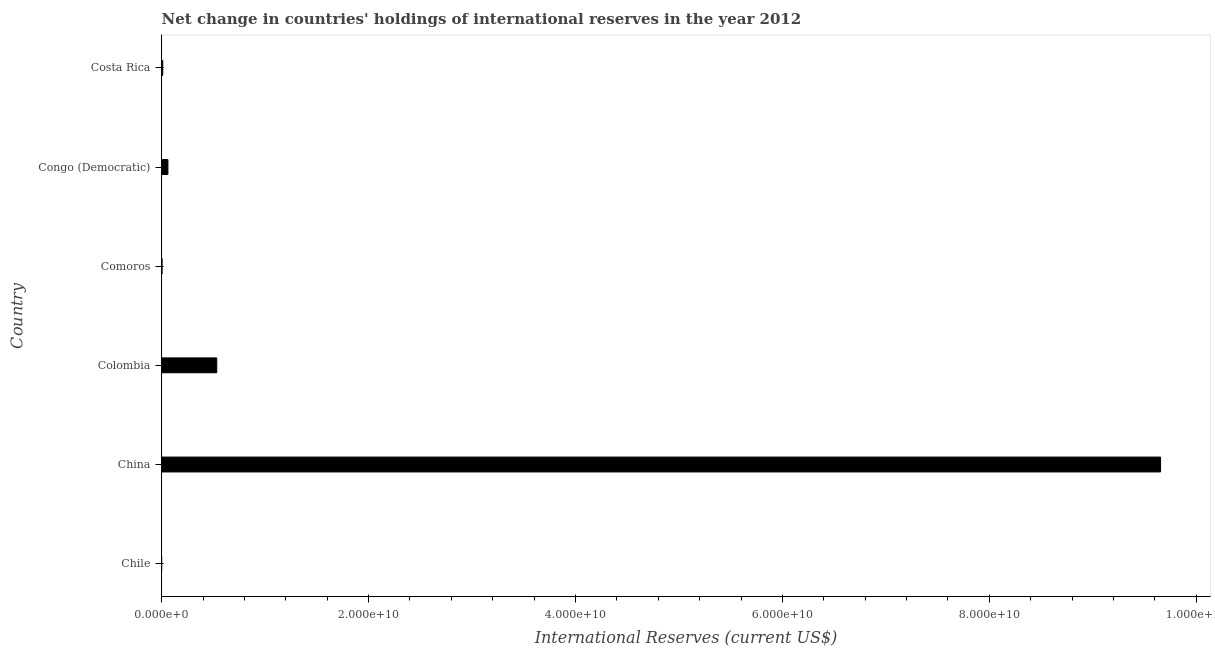What is the title of the graph?
Offer a terse response. Net change in countries' holdings of international reserves in the year 2012. What is the label or title of the X-axis?
Give a very brief answer. International Reserves (current US$). What is the reserves and related items in Comoros?
Your response must be concise. 3.07e+07. Across all countries, what is the maximum reserves and related items?
Offer a very short reply. 9.66e+1. What is the sum of the reserves and related items?
Keep it short and to the point. 1.03e+11. What is the difference between the reserves and related items in China and Comoros?
Keep it short and to the point. 9.65e+1. What is the average reserves and related items per country?
Your answer should be very brief. 1.71e+1. What is the median reserves and related items?
Give a very brief answer. 3.51e+08. In how many countries, is the reserves and related items greater than 48000000000 US$?
Offer a very short reply. 1. What is the ratio of the reserves and related items in China to that in Comoros?
Give a very brief answer. 3144.3. Is the reserves and related items in Comoros less than that in Congo (Democratic)?
Keep it short and to the point. Yes. Is the difference between the reserves and related items in China and Costa Rica greater than the difference between any two countries?
Provide a short and direct response. No. What is the difference between the highest and the second highest reserves and related items?
Your answer should be compact. 9.12e+1. Is the sum of the reserves and related items in China and Colombia greater than the maximum reserves and related items across all countries?
Your answer should be compact. Yes. What is the difference between the highest and the lowest reserves and related items?
Ensure brevity in your answer.  9.66e+1. In how many countries, is the reserves and related items greater than the average reserves and related items taken over all countries?
Provide a short and direct response. 1. Are all the bars in the graph horizontal?
Provide a short and direct response. Yes. What is the International Reserves (current US$) of China?
Ensure brevity in your answer.  9.66e+1. What is the International Reserves (current US$) in Colombia?
Make the answer very short. 5.32e+09. What is the International Reserves (current US$) of Comoros?
Give a very brief answer. 3.07e+07. What is the International Reserves (current US$) of Congo (Democratic)?
Provide a short and direct response. 6.01e+08. What is the International Reserves (current US$) in Costa Rica?
Your answer should be very brief. 1.01e+08. What is the difference between the International Reserves (current US$) in China and Colombia?
Offer a very short reply. 9.12e+1. What is the difference between the International Reserves (current US$) in China and Comoros?
Your response must be concise. 9.65e+1. What is the difference between the International Reserves (current US$) in China and Congo (Democratic)?
Your response must be concise. 9.60e+1. What is the difference between the International Reserves (current US$) in China and Costa Rica?
Provide a short and direct response. 9.65e+1. What is the difference between the International Reserves (current US$) in Colombia and Comoros?
Provide a short and direct response. 5.29e+09. What is the difference between the International Reserves (current US$) in Colombia and Congo (Democratic)?
Make the answer very short. 4.72e+09. What is the difference between the International Reserves (current US$) in Colombia and Costa Rica?
Your answer should be compact. 5.22e+09. What is the difference between the International Reserves (current US$) in Comoros and Congo (Democratic)?
Ensure brevity in your answer.  -5.70e+08. What is the difference between the International Reserves (current US$) in Comoros and Costa Rica?
Provide a succinct answer. -6.99e+07. What is the difference between the International Reserves (current US$) in Congo (Democratic) and Costa Rica?
Offer a terse response. 5.00e+08. What is the ratio of the International Reserves (current US$) in China to that in Colombia?
Your answer should be compact. 18.14. What is the ratio of the International Reserves (current US$) in China to that in Comoros?
Your answer should be very brief. 3144.3. What is the ratio of the International Reserves (current US$) in China to that in Congo (Democratic)?
Offer a terse response. 160.71. What is the ratio of the International Reserves (current US$) in China to that in Costa Rica?
Your response must be concise. 959.65. What is the ratio of the International Reserves (current US$) in Colombia to that in Comoros?
Provide a succinct answer. 173.29. What is the ratio of the International Reserves (current US$) in Colombia to that in Congo (Democratic)?
Offer a terse response. 8.86. What is the ratio of the International Reserves (current US$) in Colombia to that in Costa Rica?
Give a very brief answer. 52.89. What is the ratio of the International Reserves (current US$) in Comoros to that in Congo (Democratic)?
Provide a succinct answer. 0.05. What is the ratio of the International Reserves (current US$) in Comoros to that in Costa Rica?
Your answer should be compact. 0.3. What is the ratio of the International Reserves (current US$) in Congo (Democratic) to that in Costa Rica?
Provide a succinct answer. 5.97. 